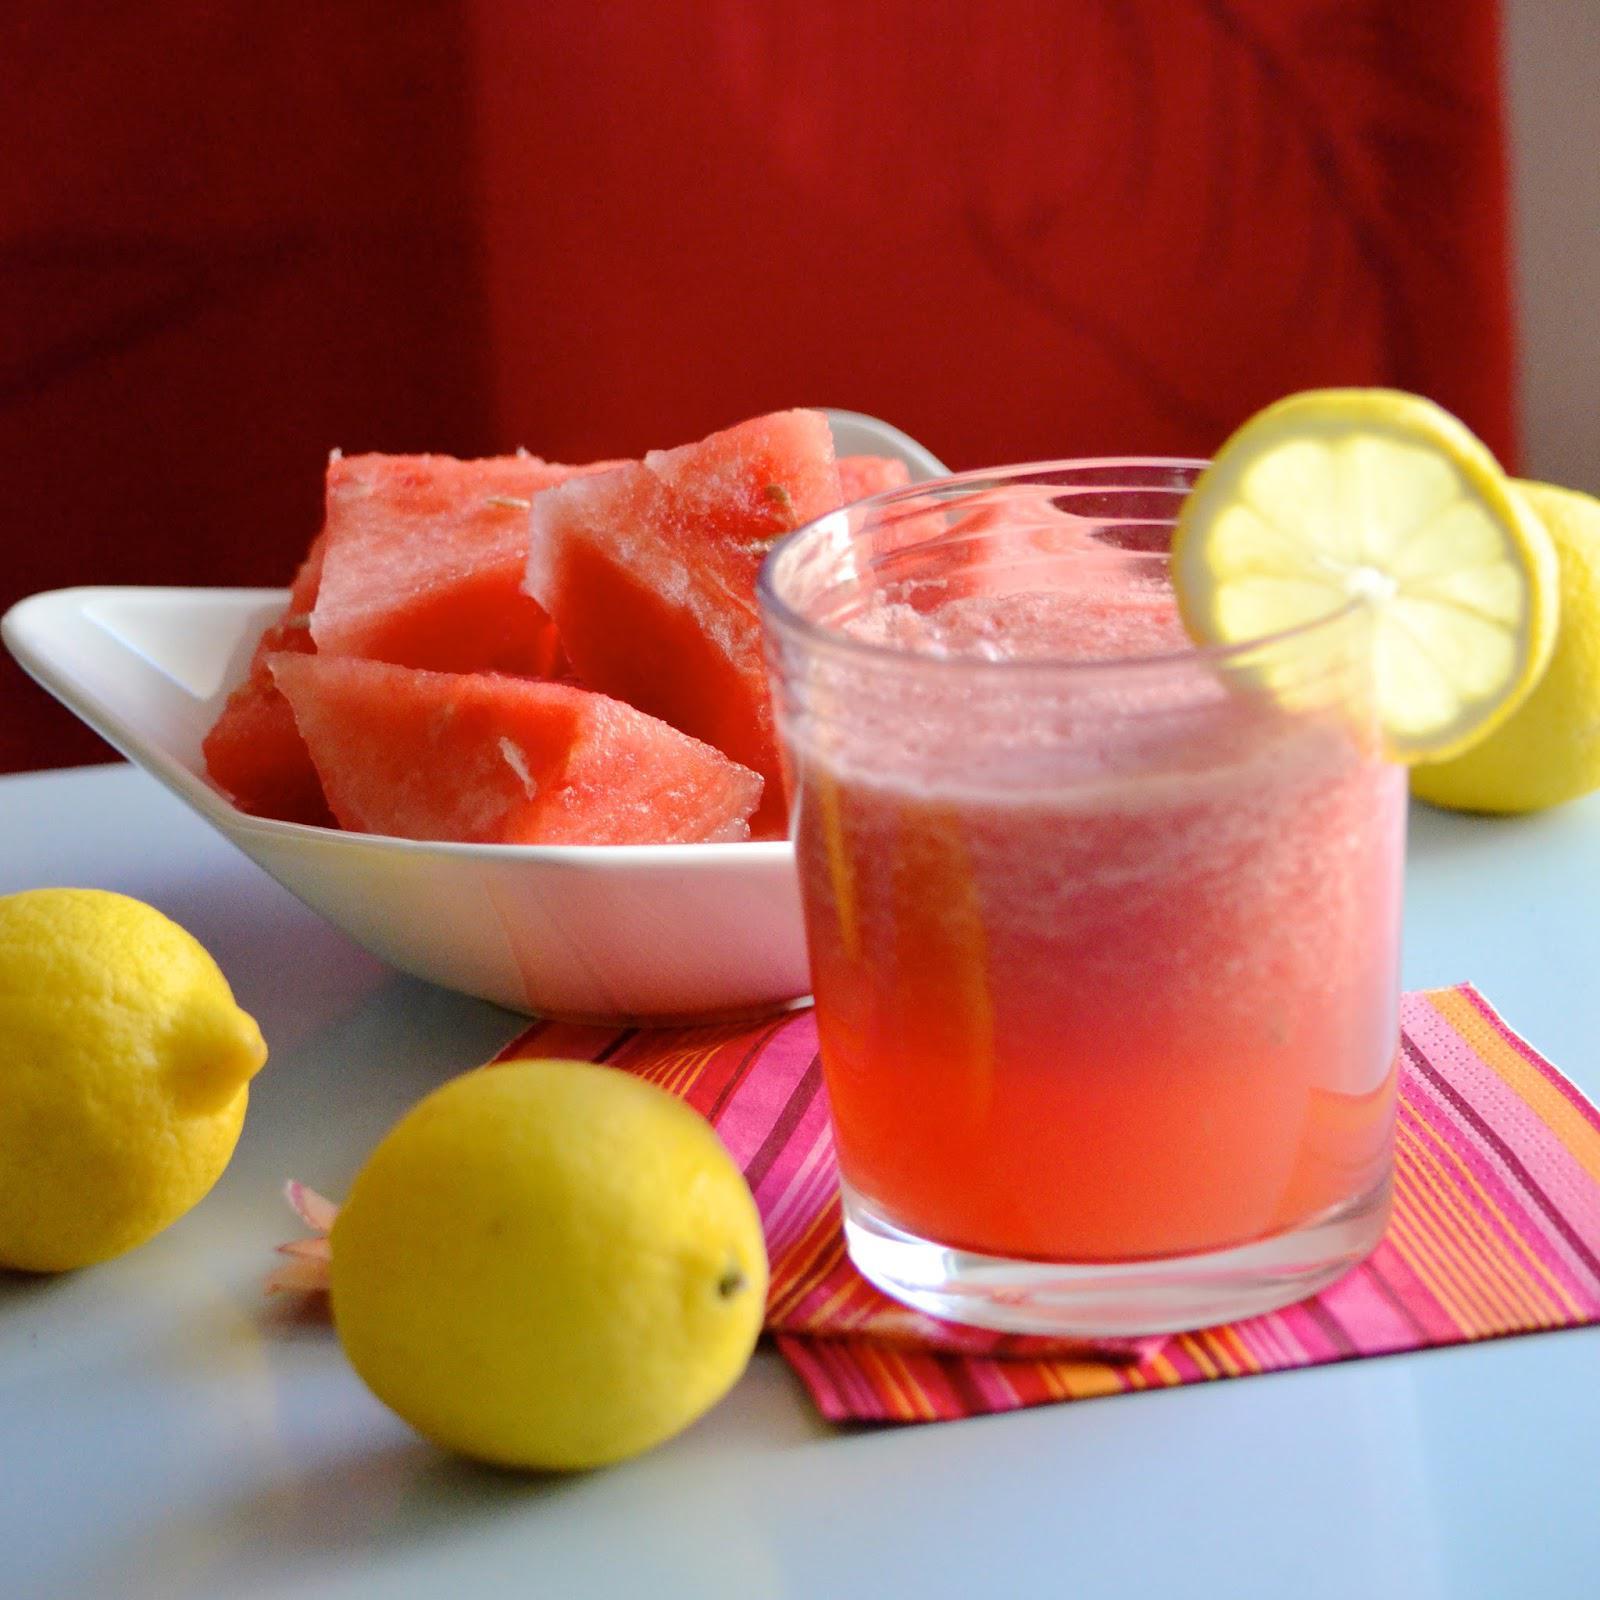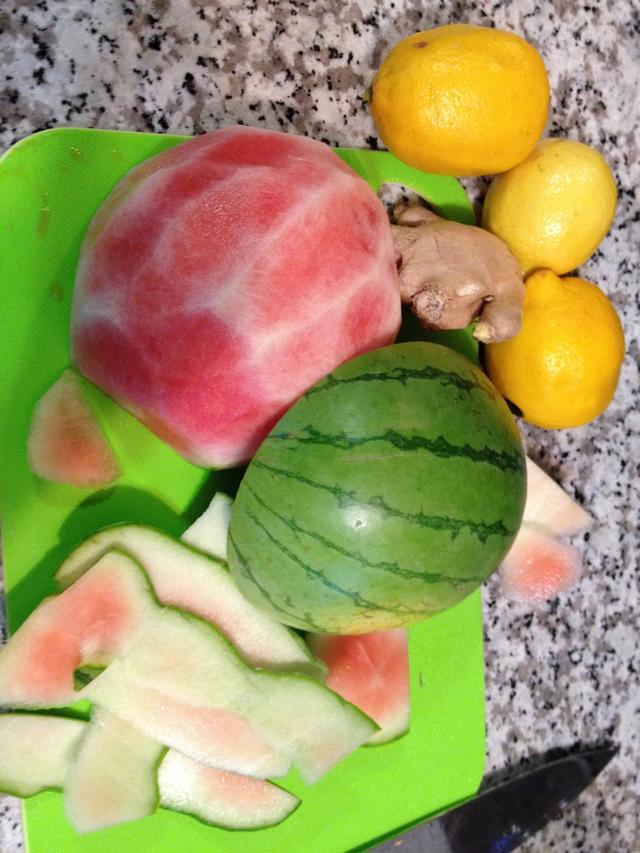The first image is the image on the left, the second image is the image on the right. Considering the images on both sides, is "At least one image features more than one whole lemon." valid? Answer yes or no. Yes. 